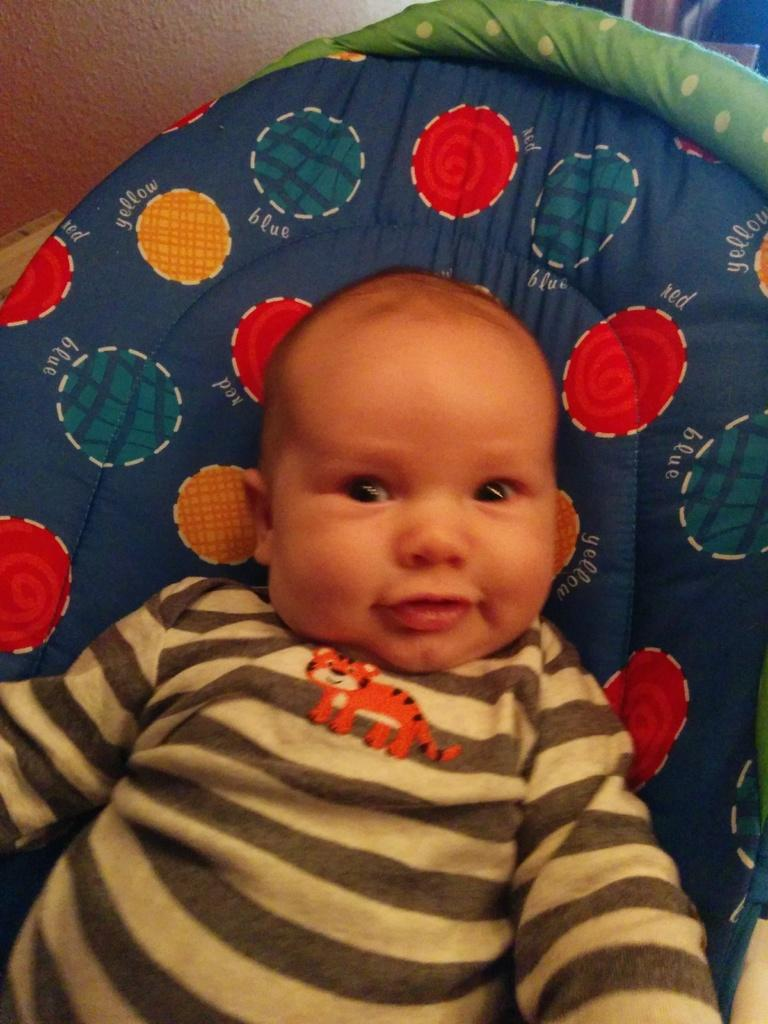What is the main subject of the image? The main subject of the image is a kid. What is the kid wearing? The kid is wearing a grey t-shirt. What is the kid sitting in? The kid is sitting in a baby traveler. What can be seen in the top left of the image? There is a wall visible in the top left of the image. Is the woman in the image sneezing? There is no woman present in the image, so it is not possible to determine if she is sneezing. 